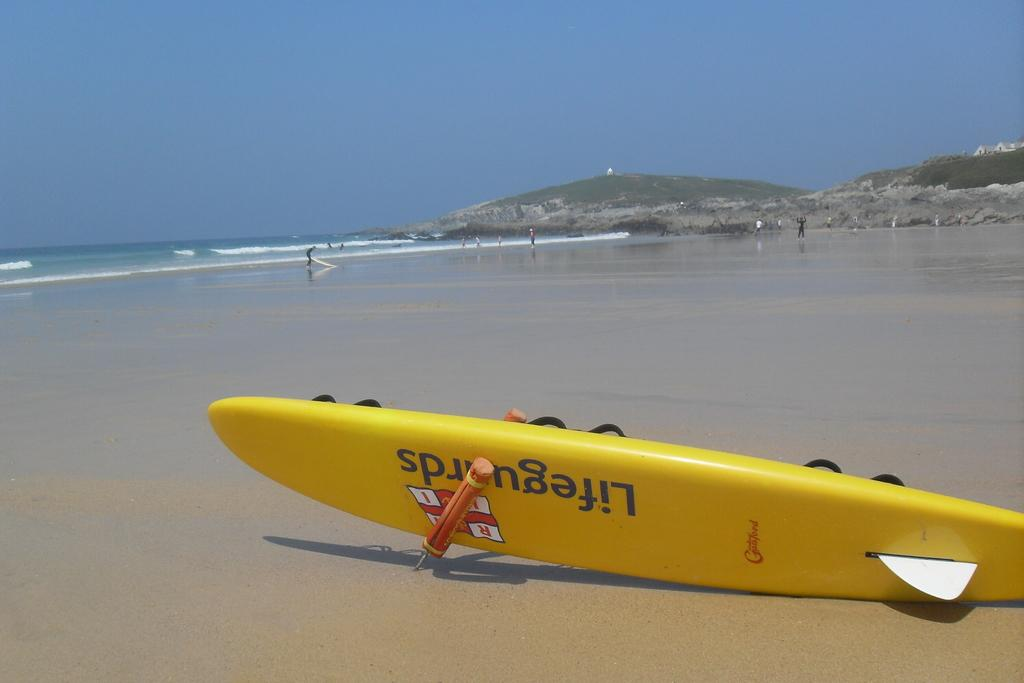<image>
Write a terse but informative summary of the picture. A yellow Lifeguards surfboard is sitting on an empty beach tipped on its side 